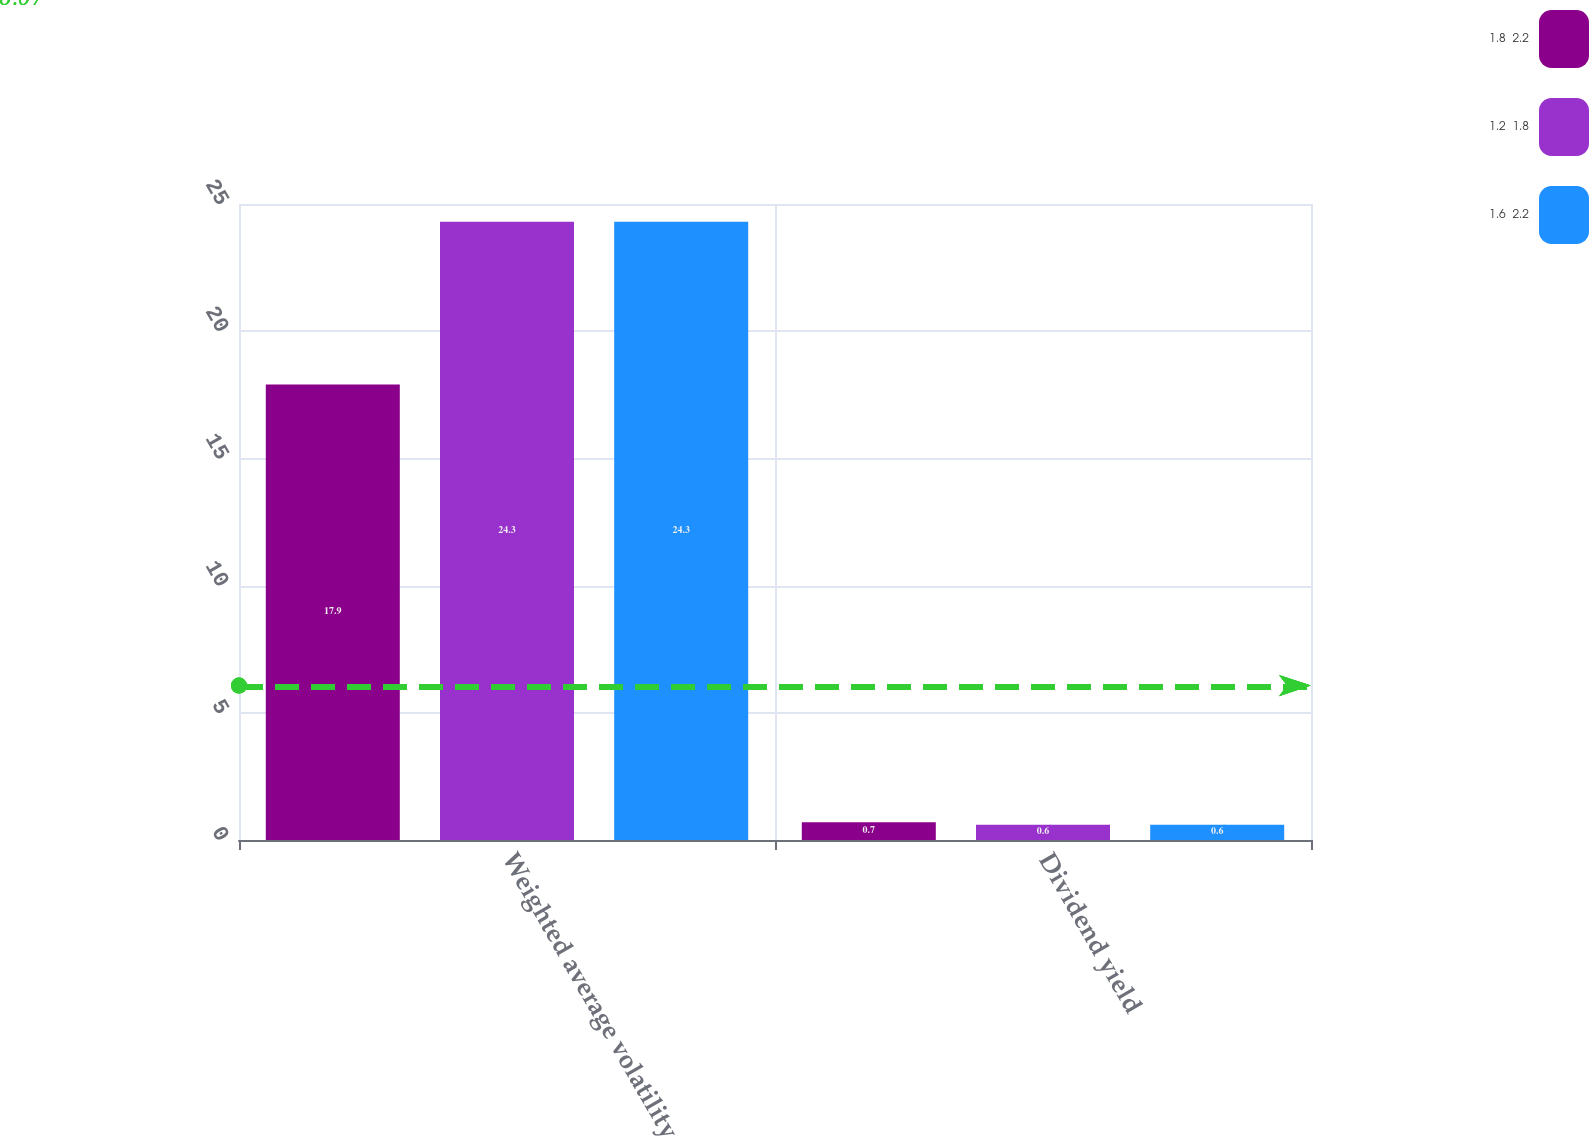Convert chart to OTSL. <chart><loc_0><loc_0><loc_500><loc_500><stacked_bar_chart><ecel><fcel>Weighted average volatility<fcel>Dividend yield<nl><fcel>1.8  2.2<fcel>17.9<fcel>0.7<nl><fcel>1.2  1.8<fcel>24.3<fcel>0.6<nl><fcel>1.6  2.2<fcel>24.3<fcel>0.6<nl></chart> 